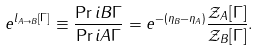<formula> <loc_0><loc_0><loc_500><loc_500>e ^ { l _ { A \to B } [ \Gamma ] } \equiv \frac { \Pr i { B } { \Gamma } } { \Pr i { A } { \Gamma } } = e ^ { - ( \eta _ { B } - \eta _ { A } ) } \frac { \mathcal { Z } _ { A } [ \Gamma ] } { \mathcal { Z } _ { B } [ \Gamma ] } .</formula> 